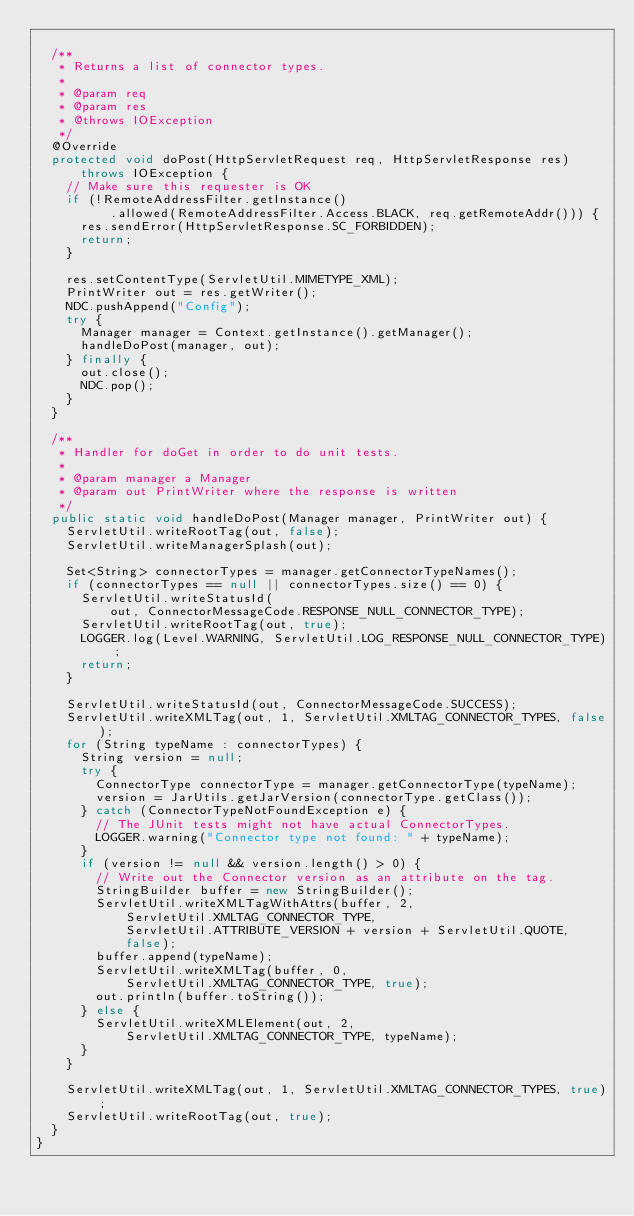Convert code to text. <code><loc_0><loc_0><loc_500><loc_500><_Java_>
  /**
   * Returns a list of connector types.
   *
   * @param req
   * @param res
   * @throws IOException
   */
  @Override
  protected void doPost(HttpServletRequest req, HttpServletResponse res)
      throws IOException {
    // Make sure this requester is OK
    if (!RemoteAddressFilter.getInstance()
          .allowed(RemoteAddressFilter.Access.BLACK, req.getRemoteAddr())) {
      res.sendError(HttpServletResponse.SC_FORBIDDEN);
      return;
    }

    res.setContentType(ServletUtil.MIMETYPE_XML);
    PrintWriter out = res.getWriter();
    NDC.pushAppend("Config");
    try {
      Manager manager = Context.getInstance().getManager();
      handleDoPost(manager, out);
    } finally {
      out.close();
      NDC.pop();
    }
  }

  /**
   * Handler for doGet in order to do unit tests.
   *
   * @param manager a Manager
   * @param out PrintWriter where the response is written
   */
  public static void handleDoPost(Manager manager, PrintWriter out) {
    ServletUtil.writeRootTag(out, false);
    ServletUtil.writeManagerSplash(out);

    Set<String> connectorTypes = manager.getConnectorTypeNames();
    if (connectorTypes == null || connectorTypes.size() == 0) {
      ServletUtil.writeStatusId(
          out, ConnectorMessageCode.RESPONSE_NULL_CONNECTOR_TYPE);
      ServletUtil.writeRootTag(out, true);
      LOGGER.log(Level.WARNING, ServletUtil.LOG_RESPONSE_NULL_CONNECTOR_TYPE);
      return;
    }

    ServletUtil.writeStatusId(out, ConnectorMessageCode.SUCCESS);
    ServletUtil.writeXMLTag(out, 1, ServletUtil.XMLTAG_CONNECTOR_TYPES, false);
    for (String typeName : connectorTypes) {
      String version = null;
      try {
        ConnectorType connectorType = manager.getConnectorType(typeName);
        version = JarUtils.getJarVersion(connectorType.getClass());
      } catch (ConnectorTypeNotFoundException e) {
        // The JUnit tests might not have actual ConnectorTypes.
        LOGGER.warning("Connector type not found: " + typeName);
      }
      if (version != null && version.length() > 0) {
        // Write out the Connector version as an attribute on the tag.
        StringBuilder buffer = new StringBuilder();
        ServletUtil.writeXMLTagWithAttrs(buffer, 2,
            ServletUtil.XMLTAG_CONNECTOR_TYPE,
            ServletUtil.ATTRIBUTE_VERSION + version + ServletUtil.QUOTE,
            false);
        buffer.append(typeName);
        ServletUtil.writeXMLTag(buffer, 0,
            ServletUtil.XMLTAG_CONNECTOR_TYPE, true);
        out.println(buffer.toString());
      } else {
        ServletUtil.writeXMLElement(out, 2,
            ServletUtil.XMLTAG_CONNECTOR_TYPE, typeName);
      }
    }

    ServletUtil.writeXMLTag(out, 1, ServletUtil.XMLTAG_CONNECTOR_TYPES, true);
    ServletUtil.writeRootTag(out, true);
  }
}
</code> 